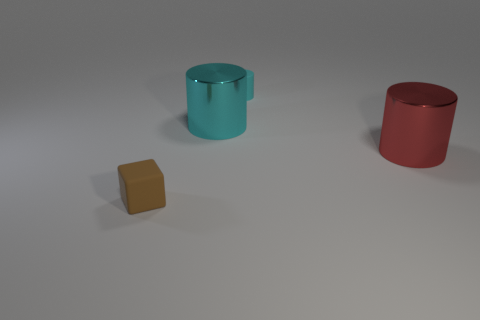There is a large red thing; is its shape the same as the rubber object behind the matte block?
Provide a short and direct response. Yes. What number of things are either large gray rubber objects or rubber objects?
Offer a terse response. 2. The small thing in front of the small matte object that is behind the brown object is what shape?
Offer a very short reply. Cube. There is a tiny matte object right of the rubber cube; does it have the same shape as the brown rubber thing?
Provide a succinct answer. No. The other cylinder that is made of the same material as the red cylinder is what size?
Keep it short and to the point. Large. What number of objects are objects in front of the small cyan matte thing or matte objects that are right of the tiny rubber cube?
Provide a short and direct response. 4. Are there an equal number of cubes that are in front of the tiny brown matte cube and small cyan rubber cylinders on the left side of the cyan rubber object?
Offer a very short reply. Yes. There is a rubber thing that is behind the block; what is its color?
Your response must be concise. Cyan. Does the small cylinder have the same color as the large cylinder on the left side of the small matte cylinder?
Give a very brief answer. Yes. Is the number of small purple spheres less than the number of brown cubes?
Make the answer very short. Yes. 